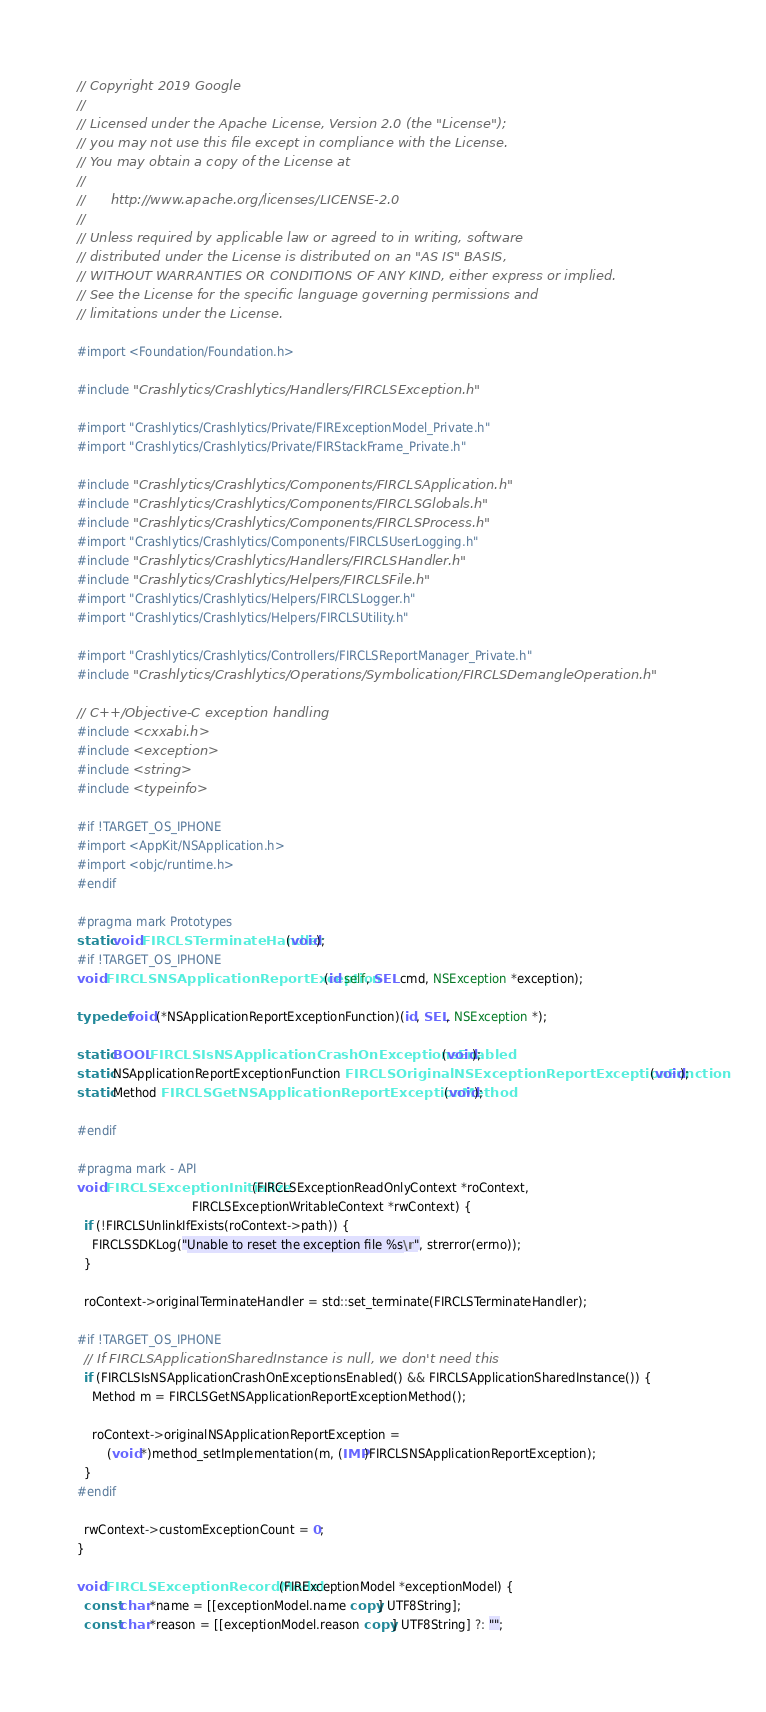<code> <loc_0><loc_0><loc_500><loc_500><_ObjectiveC_>// Copyright 2019 Google
//
// Licensed under the Apache License, Version 2.0 (the "License");
// you may not use this file except in compliance with the License.
// You may obtain a copy of the License at
//
//      http://www.apache.org/licenses/LICENSE-2.0
//
// Unless required by applicable law or agreed to in writing, software
// distributed under the License is distributed on an "AS IS" BASIS,
// WITHOUT WARRANTIES OR CONDITIONS OF ANY KIND, either express or implied.
// See the License for the specific language governing permissions and
// limitations under the License.

#import <Foundation/Foundation.h>

#include "Crashlytics/Crashlytics/Handlers/FIRCLSException.h"

#import "Crashlytics/Crashlytics/Private/FIRExceptionModel_Private.h"
#import "Crashlytics/Crashlytics/Private/FIRStackFrame_Private.h"

#include "Crashlytics/Crashlytics/Components/FIRCLSApplication.h"
#include "Crashlytics/Crashlytics/Components/FIRCLSGlobals.h"
#include "Crashlytics/Crashlytics/Components/FIRCLSProcess.h"
#import "Crashlytics/Crashlytics/Components/FIRCLSUserLogging.h"
#include "Crashlytics/Crashlytics/Handlers/FIRCLSHandler.h"
#include "Crashlytics/Crashlytics/Helpers/FIRCLSFile.h"
#import "Crashlytics/Crashlytics/Helpers/FIRCLSLogger.h"
#import "Crashlytics/Crashlytics/Helpers/FIRCLSUtility.h"

#import "Crashlytics/Crashlytics/Controllers/FIRCLSReportManager_Private.h"
#include "Crashlytics/Crashlytics/Operations/Symbolication/FIRCLSDemangleOperation.h"

// C++/Objective-C exception handling
#include <cxxabi.h>
#include <exception>
#include <string>
#include <typeinfo>

#if !TARGET_OS_IPHONE
#import <AppKit/NSApplication.h>
#import <objc/runtime.h>
#endif

#pragma mark Prototypes
static void FIRCLSTerminateHandler(void);
#if !TARGET_OS_IPHONE
void FIRCLSNSApplicationReportException(id self, SEL cmd, NSException *exception);

typedef void (*NSApplicationReportExceptionFunction)(id, SEL, NSException *);

static BOOL FIRCLSIsNSApplicationCrashOnExceptionsEnabled(void);
static NSApplicationReportExceptionFunction FIRCLSOriginalNSExceptionReportExceptionFunction(void);
static Method FIRCLSGetNSApplicationReportExceptionMethod(void);

#endif

#pragma mark - API
void FIRCLSExceptionInitialize(FIRCLSExceptionReadOnlyContext *roContext,
                               FIRCLSExceptionWritableContext *rwContext) {
  if (!FIRCLSUnlinkIfExists(roContext->path)) {
    FIRCLSSDKLog("Unable to reset the exception file %s\n", strerror(errno));
  }

  roContext->originalTerminateHandler = std::set_terminate(FIRCLSTerminateHandler);

#if !TARGET_OS_IPHONE
  // If FIRCLSApplicationSharedInstance is null, we don't need this
  if (FIRCLSIsNSApplicationCrashOnExceptionsEnabled() && FIRCLSApplicationSharedInstance()) {
    Method m = FIRCLSGetNSApplicationReportExceptionMethod();

    roContext->originalNSApplicationReportException =
        (void *)method_setImplementation(m, (IMP)FIRCLSNSApplicationReportException);
  }
#endif

  rwContext->customExceptionCount = 0;
}

void FIRCLSExceptionRecordModel(FIRExceptionModel *exceptionModel) {
  const char *name = [[exceptionModel.name copy] UTF8String];
  const char *reason = [[exceptionModel.reason copy] UTF8String] ?: "";
</code> 